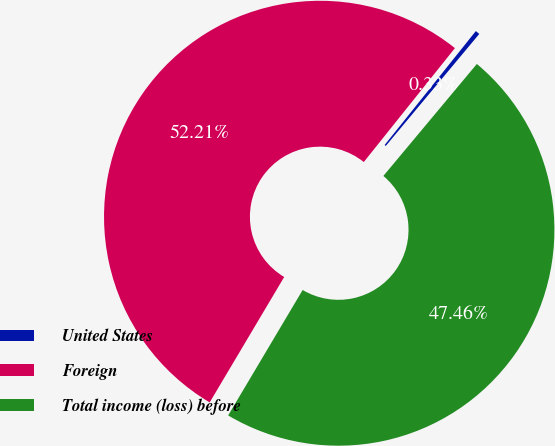Convert chart to OTSL. <chart><loc_0><loc_0><loc_500><loc_500><pie_chart><fcel>United States<fcel>Foreign<fcel>Total income (loss) before<nl><fcel>0.33%<fcel>52.21%<fcel>47.46%<nl></chart> 